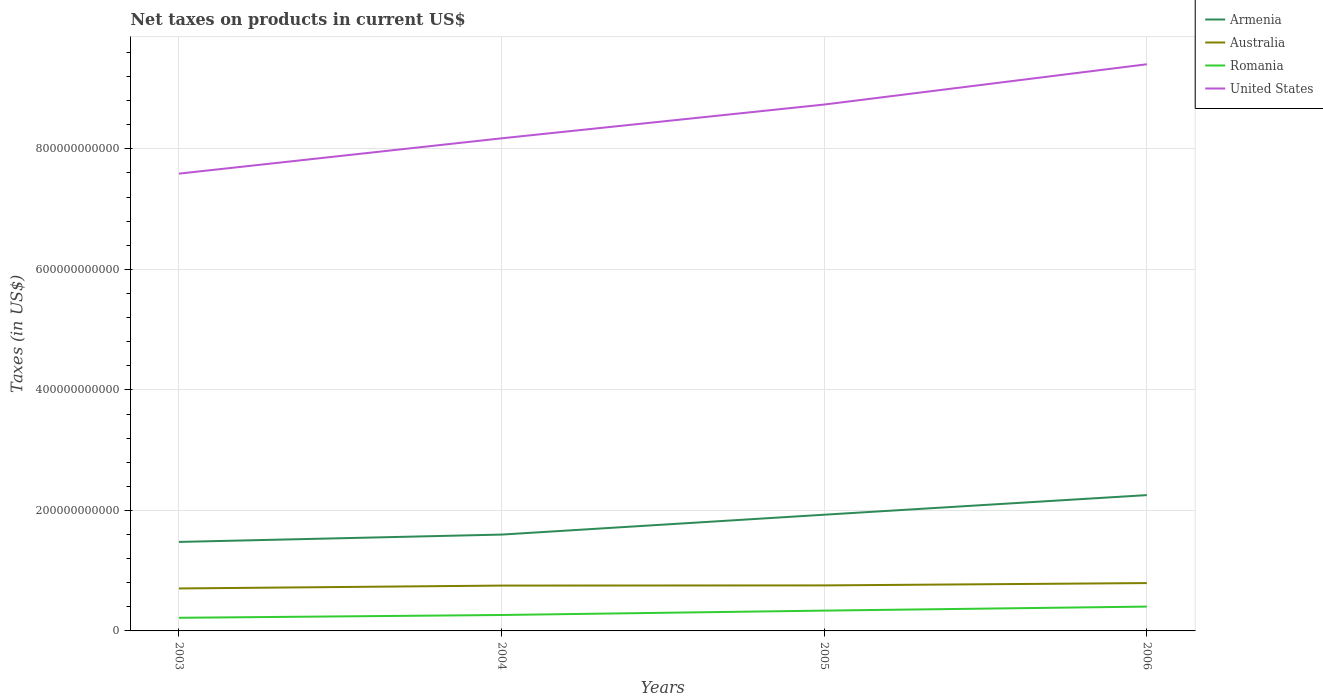How many different coloured lines are there?
Offer a very short reply. 4. Is the number of lines equal to the number of legend labels?
Offer a terse response. Yes. Across all years, what is the maximum net taxes on products in United States?
Offer a very short reply. 7.59e+11. In which year was the net taxes on products in United States maximum?
Your answer should be compact. 2003. What is the total net taxes on products in Armenia in the graph?
Keep it short and to the point. -6.55e+1. What is the difference between the highest and the second highest net taxes on products in Armenia?
Make the answer very short. 7.77e+1. How many years are there in the graph?
Make the answer very short. 4. What is the difference between two consecutive major ticks on the Y-axis?
Give a very brief answer. 2.00e+11. Does the graph contain grids?
Give a very brief answer. Yes. How many legend labels are there?
Keep it short and to the point. 4. What is the title of the graph?
Ensure brevity in your answer.  Net taxes on products in current US$. What is the label or title of the X-axis?
Your answer should be very brief. Years. What is the label or title of the Y-axis?
Offer a very short reply. Taxes (in US$). What is the Taxes (in US$) in Armenia in 2003?
Provide a succinct answer. 1.48e+11. What is the Taxes (in US$) in Australia in 2003?
Keep it short and to the point. 7.05e+1. What is the Taxes (in US$) of Romania in 2003?
Provide a succinct answer. 2.18e+1. What is the Taxes (in US$) in United States in 2003?
Offer a terse response. 7.59e+11. What is the Taxes (in US$) of Armenia in 2004?
Give a very brief answer. 1.60e+11. What is the Taxes (in US$) of Australia in 2004?
Offer a terse response. 7.53e+1. What is the Taxes (in US$) in Romania in 2004?
Offer a terse response. 2.64e+1. What is the Taxes (in US$) in United States in 2004?
Keep it short and to the point. 8.18e+11. What is the Taxes (in US$) of Armenia in 2005?
Provide a short and direct response. 1.93e+11. What is the Taxes (in US$) of Australia in 2005?
Make the answer very short. 7.55e+1. What is the Taxes (in US$) in Romania in 2005?
Your answer should be compact. 3.37e+1. What is the Taxes (in US$) of United States in 2005?
Your response must be concise. 8.74e+11. What is the Taxes (in US$) in Armenia in 2006?
Offer a terse response. 2.25e+11. What is the Taxes (in US$) in Australia in 2006?
Offer a very short reply. 7.94e+1. What is the Taxes (in US$) in Romania in 2006?
Provide a succinct answer. 4.04e+1. What is the Taxes (in US$) in United States in 2006?
Ensure brevity in your answer.  9.40e+11. Across all years, what is the maximum Taxes (in US$) of Armenia?
Ensure brevity in your answer.  2.25e+11. Across all years, what is the maximum Taxes (in US$) of Australia?
Make the answer very short. 7.94e+1. Across all years, what is the maximum Taxes (in US$) in Romania?
Keep it short and to the point. 4.04e+1. Across all years, what is the maximum Taxes (in US$) in United States?
Ensure brevity in your answer.  9.40e+11. Across all years, what is the minimum Taxes (in US$) in Armenia?
Your answer should be very brief. 1.48e+11. Across all years, what is the minimum Taxes (in US$) of Australia?
Your answer should be very brief. 7.05e+1. Across all years, what is the minimum Taxes (in US$) in Romania?
Ensure brevity in your answer.  2.18e+1. Across all years, what is the minimum Taxes (in US$) of United States?
Your answer should be very brief. 7.59e+11. What is the total Taxes (in US$) of Armenia in the graph?
Offer a very short reply. 7.26e+11. What is the total Taxes (in US$) of Australia in the graph?
Provide a short and direct response. 3.01e+11. What is the total Taxes (in US$) in Romania in the graph?
Keep it short and to the point. 1.22e+11. What is the total Taxes (in US$) of United States in the graph?
Keep it short and to the point. 3.39e+12. What is the difference between the Taxes (in US$) of Armenia in 2003 and that in 2004?
Offer a terse response. -1.22e+1. What is the difference between the Taxes (in US$) in Australia in 2003 and that in 2004?
Offer a terse response. -4.78e+09. What is the difference between the Taxes (in US$) in Romania in 2003 and that in 2004?
Ensure brevity in your answer.  -4.65e+09. What is the difference between the Taxes (in US$) in United States in 2003 and that in 2004?
Make the answer very short. -5.86e+1. What is the difference between the Taxes (in US$) in Armenia in 2003 and that in 2005?
Provide a succinct answer. -4.52e+1. What is the difference between the Taxes (in US$) in Australia in 2003 and that in 2005?
Make the answer very short. -5.05e+09. What is the difference between the Taxes (in US$) in Romania in 2003 and that in 2005?
Give a very brief answer. -1.19e+1. What is the difference between the Taxes (in US$) of United States in 2003 and that in 2005?
Provide a short and direct response. -1.15e+11. What is the difference between the Taxes (in US$) in Armenia in 2003 and that in 2006?
Provide a short and direct response. -7.77e+1. What is the difference between the Taxes (in US$) in Australia in 2003 and that in 2006?
Offer a terse response. -8.92e+09. What is the difference between the Taxes (in US$) of Romania in 2003 and that in 2006?
Ensure brevity in your answer.  -1.86e+1. What is the difference between the Taxes (in US$) in United States in 2003 and that in 2006?
Your response must be concise. -1.82e+11. What is the difference between the Taxes (in US$) in Armenia in 2004 and that in 2005?
Offer a very short reply. -3.30e+1. What is the difference between the Taxes (in US$) in Australia in 2004 and that in 2005?
Your response must be concise. -2.70e+08. What is the difference between the Taxes (in US$) of Romania in 2004 and that in 2005?
Offer a very short reply. -7.29e+09. What is the difference between the Taxes (in US$) of United States in 2004 and that in 2005?
Keep it short and to the point. -5.61e+1. What is the difference between the Taxes (in US$) of Armenia in 2004 and that in 2006?
Give a very brief answer. -6.55e+1. What is the difference between the Taxes (in US$) in Australia in 2004 and that in 2006?
Provide a short and direct response. -4.14e+09. What is the difference between the Taxes (in US$) in Romania in 2004 and that in 2006?
Your response must be concise. -1.39e+1. What is the difference between the Taxes (in US$) of United States in 2004 and that in 2006?
Your response must be concise. -1.23e+11. What is the difference between the Taxes (in US$) in Armenia in 2005 and that in 2006?
Offer a very short reply. -3.25e+1. What is the difference between the Taxes (in US$) of Australia in 2005 and that in 2006?
Provide a short and direct response. -3.87e+09. What is the difference between the Taxes (in US$) in Romania in 2005 and that in 2006?
Your response must be concise. -6.66e+09. What is the difference between the Taxes (in US$) in United States in 2005 and that in 2006?
Ensure brevity in your answer.  -6.69e+1. What is the difference between the Taxes (in US$) of Armenia in 2003 and the Taxes (in US$) of Australia in 2004?
Your answer should be compact. 7.24e+1. What is the difference between the Taxes (in US$) in Armenia in 2003 and the Taxes (in US$) in Romania in 2004?
Make the answer very short. 1.21e+11. What is the difference between the Taxes (in US$) of Armenia in 2003 and the Taxes (in US$) of United States in 2004?
Keep it short and to the point. -6.70e+11. What is the difference between the Taxes (in US$) in Australia in 2003 and the Taxes (in US$) in Romania in 2004?
Provide a succinct answer. 4.40e+1. What is the difference between the Taxes (in US$) of Australia in 2003 and the Taxes (in US$) of United States in 2004?
Provide a succinct answer. -7.47e+11. What is the difference between the Taxes (in US$) of Romania in 2003 and the Taxes (in US$) of United States in 2004?
Offer a very short reply. -7.96e+11. What is the difference between the Taxes (in US$) in Armenia in 2003 and the Taxes (in US$) in Australia in 2005?
Offer a terse response. 7.22e+1. What is the difference between the Taxes (in US$) of Armenia in 2003 and the Taxes (in US$) of Romania in 2005?
Keep it short and to the point. 1.14e+11. What is the difference between the Taxes (in US$) of Armenia in 2003 and the Taxes (in US$) of United States in 2005?
Provide a short and direct response. -7.26e+11. What is the difference between the Taxes (in US$) of Australia in 2003 and the Taxes (in US$) of Romania in 2005?
Give a very brief answer. 3.68e+1. What is the difference between the Taxes (in US$) of Australia in 2003 and the Taxes (in US$) of United States in 2005?
Keep it short and to the point. -8.03e+11. What is the difference between the Taxes (in US$) in Romania in 2003 and the Taxes (in US$) in United States in 2005?
Give a very brief answer. -8.52e+11. What is the difference between the Taxes (in US$) in Armenia in 2003 and the Taxes (in US$) in Australia in 2006?
Offer a terse response. 6.83e+1. What is the difference between the Taxes (in US$) of Armenia in 2003 and the Taxes (in US$) of Romania in 2006?
Provide a short and direct response. 1.07e+11. What is the difference between the Taxes (in US$) in Armenia in 2003 and the Taxes (in US$) in United States in 2006?
Your answer should be very brief. -7.93e+11. What is the difference between the Taxes (in US$) in Australia in 2003 and the Taxes (in US$) in Romania in 2006?
Keep it short and to the point. 3.01e+1. What is the difference between the Taxes (in US$) in Australia in 2003 and the Taxes (in US$) in United States in 2006?
Provide a short and direct response. -8.70e+11. What is the difference between the Taxes (in US$) of Romania in 2003 and the Taxes (in US$) of United States in 2006?
Keep it short and to the point. -9.19e+11. What is the difference between the Taxes (in US$) in Armenia in 2004 and the Taxes (in US$) in Australia in 2005?
Your answer should be compact. 8.44e+1. What is the difference between the Taxes (in US$) in Armenia in 2004 and the Taxes (in US$) in Romania in 2005?
Offer a terse response. 1.26e+11. What is the difference between the Taxes (in US$) in Armenia in 2004 and the Taxes (in US$) in United States in 2005?
Provide a short and direct response. -7.14e+11. What is the difference between the Taxes (in US$) in Australia in 2004 and the Taxes (in US$) in Romania in 2005?
Your response must be concise. 4.15e+1. What is the difference between the Taxes (in US$) of Australia in 2004 and the Taxes (in US$) of United States in 2005?
Offer a terse response. -7.98e+11. What is the difference between the Taxes (in US$) of Romania in 2004 and the Taxes (in US$) of United States in 2005?
Your answer should be compact. -8.47e+11. What is the difference between the Taxes (in US$) in Armenia in 2004 and the Taxes (in US$) in Australia in 2006?
Keep it short and to the point. 8.05e+1. What is the difference between the Taxes (in US$) in Armenia in 2004 and the Taxes (in US$) in Romania in 2006?
Offer a terse response. 1.20e+11. What is the difference between the Taxes (in US$) of Armenia in 2004 and the Taxes (in US$) of United States in 2006?
Make the answer very short. -7.81e+11. What is the difference between the Taxes (in US$) in Australia in 2004 and the Taxes (in US$) in Romania in 2006?
Give a very brief answer. 3.49e+1. What is the difference between the Taxes (in US$) in Australia in 2004 and the Taxes (in US$) in United States in 2006?
Offer a very short reply. -8.65e+11. What is the difference between the Taxes (in US$) in Romania in 2004 and the Taxes (in US$) in United States in 2006?
Ensure brevity in your answer.  -9.14e+11. What is the difference between the Taxes (in US$) of Armenia in 2005 and the Taxes (in US$) of Australia in 2006?
Provide a short and direct response. 1.13e+11. What is the difference between the Taxes (in US$) in Armenia in 2005 and the Taxes (in US$) in Romania in 2006?
Provide a succinct answer. 1.52e+11. What is the difference between the Taxes (in US$) in Armenia in 2005 and the Taxes (in US$) in United States in 2006?
Your response must be concise. -7.48e+11. What is the difference between the Taxes (in US$) in Australia in 2005 and the Taxes (in US$) in Romania in 2006?
Ensure brevity in your answer.  3.52e+1. What is the difference between the Taxes (in US$) of Australia in 2005 and the Taxes (in US$) of United States in 2006?
Provide a succinct answer. -8.65e+11. What is the difference between the Taxes (in US$) of Romania in 2005 and the Taxes (in US$) of United States in 2006?
Your answer should be very brief. -9.07e+11. What is the average Taxes (in US$) of Armenia per year?
Provide a short and direct response. 1.81e+11. What is the average Taxes (in US$) of Australia per year?
Your answer should be very brief. 7.52e+1. What is the average Taxes (in US$) in Romania per year?
Keep it short and to the point. 3.06e+1. What is the average Taxes (in US$) in United States per year?
Make the answer very short. 8.48e+11. In the year 2003, what is the difference between the Taxes (in US$) in Armenia and Taxes (in US$) in Australia?
Ensure brevity in your answer.  7.72e+1. In the year 2003, what is the difference between the Taxes (in US$) in Armenia and Taxes (in US$) in Romania?
Keep it short and to the point. 1.26e+11. In the year 2003, what is the difference between the Taxes (in US$) in Armenia and Taxes (in US$) in United States?
Your response must be concise. -6.11e+11. In the year 2003, what is the difference between the Taxes (in US$) in Australia and Taxes (in US$) in Romania?
Ensure brevity in your answer.  4.87e+1. In the year 2003, what is the difference between the Taxes (in US$) in Australia and Taxes (in US$) in United States?
Ensure brevity in your answer.  -6.88e+11. In the year 2003, what is the difference between the Taxes (in US$) in Romania and Taxes (in US$) in United States?
Offer a terse response. -7.37e+11. In the year 2004, what is the difference between the Taxes (in US$) of Armenia and Taxes (in US$) of Australia?
Offer a very short reply. 8.46e+1. In the year 2004, what is the difference between the Taxes (in US$) in Armenia and Taxes (in US$) in Romania?
Offer a terse response. 1.33e+11. In the year 2004, what is the difference between the Taxes (in US$) in Armenia and Taxes (in US$) in United States?
Provide a short and direct response. -6.58e+11. In the year 2004, what is the difference between the Taxes (in US$) of Australia and Taxes (in US$) of Romania?
Provide a short and direct response. 4.88e+1. In the year 2004, what is the difference between the Taxes (in US$) in Australia and Taxes (in US$) in United States?
Provide a succinct answer. -7.42e+11. In the year 2004, what is the difference between the Taxes (in US$) of Romania and Taxes (in US$) of United States?
Your response must be concise. -7.91e+11. In the year 2005, what is the difference between the Taxes (in US$) of Armenia and Taxes (in US$) of Australia?
Provide a short and direct response. 1.17e+11. In the year 2005, what is the difference between the Taxes (in US$) of Armenia and Taxes (in US$) of Romania?
Offer a terse response. 1.59e+11. In the year 2005, what is the difference between the Taxes (in US$) in Armenia and Taxes (in US$) in United States?
Offer a very short reply. -6.81e+11. In the year 2005, what is the difference between the Taxes (in US$) of Australia and Taxes (in US$) of Romania?
Your answer should be compact. 4.18e+1. In the year 2005, what is the difference between the Taxes (in US$) in Australia and Taxes (in US$) in United States?
Provide a short and direct response. -7.98e+11. In the year 2005, what is the difference between the Taxes (in US$) in Romania and Taxes (in US$) in United States?
Provide a short and direct response. -8.40e+11. In the year 2006, what is the difference between the Taxes (in US$) of Armenia and Taxes (in US$) of Australia?
Your answer should be compact. 1.46e+11. In the year 2006, what is the difference between the Taxes (in US$) in Armenia and Taxes (in US$) in Romania?
Offer a very short reply. 1.85e+11. In the year 2006, what is the difference between the Taxes (in US$) of Armenia and Taxes (in US$) of United States?
Your response must be concise. -7.15e+11. In the year 2006, what is the difference between the Taxes (in US$) of Australia and Taxes (in US$) of Romania?
Ensure brevity in your answer.  3.90e+1. In the year 2006, what is the difference between the Taxes (in US$) in Australia and Taxes (in US$) in United States?
Offer a very short reply. -8.61e+11. In the year 2006, what is the difference between the Taxes (in US$) of Romania and Taxes (in US$) of United States?
Give a very brief answer. -9.00e+11. What is the ratio of the Taxes (in US$) of Armenia in 2003 to that in 2004?
Provide a succinct answer. 0.92. What is the ratio of the Taxes (in US$) of Australia in 2003 to that in 2004?
Keep it short and to the point. 0.94. What is the ratio of the Taxes (in US$) of Romania in 2003 to that in 2004?
Offer a terse response. 0.82. What is the ratio of the Taxes (in US$) of United States in 2003 to that in 2004?
Keep it short and to the point. 0.93. What is the ratio of the Taxes (in US$) of Armenia in 2003 to that in 2005?
Make the answer very short. 0.77. What is the ratio of the Taxes (in US$) of Australia in 2003 to that in 2005?
Your answer should be compact. 0.93. What is the ratio of the Taxes (in US$) in Romania in 2003 to that in 2005?
Your answer should be very brief. 0.65. What is the ratio of the Taxes (in US$) in United States in 2003 to that in 2005?
Ensure brevity in your answer.  0.87. What is the ratio of the Taxes (in US$) in Armenia in 2003 to that in 2006?
Offer a terse response. 0.66. What is the ratio of the Taxes (in US$) of Australia in 2003 to that in 2006?
Your answer should be very brief. 0.89. What is the ratio of the Taxes (in US$) in Romania in 2003 to that in 2006?
Offer a very short reply. 0.54. What is the ratio of the Taxes (in US$) in United States in 2003 to that in 2006?
Keep it short and to the point. 0.81. What is the ratio of the Taxes (in US$) of Armenia in 2004 to that in 2005?
Provide a succinct answer. 0.83. What is the ratio of the Taxes (in US$) of Romania in 2004 to that in 2005?
Offer a very short reply. 0.78. What is the ratio of the Taxes (in US$) in United States in 2004 to that in 2005?
Give a very brief answer. 0.94. What is the ratio of the Taxes (in US$) of Armenia in 2004 to that in 2006?
Your answer should be very brief. 0.71. What is the ratio of the Taxes (in US$) in Australia in 2004 to that in 2006?
Offer a terse response. 0.95. What is the ratio of the Taxes (in US$) in Romania in 2004 to that in 2006?
Provide a succinct answer. 0.65. What is the ratio of the Taxes (in US$) in United States in 2004 to that in 2006?
Offer a terse response. 0.87. What is the ratio of the Taxes (in US$) in Armenia in 2005 to that in 2006?
Offer a very short reply. 0.86. What is the ratio of the Taxes (in US$) in Australia in 2005 to that in 2006?
Give a very brief answer. 0.95. What is the ratio of the Taxes (in US$) in Romania in 2005 to that in 2006?
Provide a succinct answer. 0.84. What is the ratio of the Taxes (in US$) in United States in 2005 to that in 2006?
Offer a very short reply. 0.93. What is the difference between the highest and the second highest Taxes (in US$) of Armenia?
Give a very brief answer. 3.25e+1. What is the difference between the highest and the second highest Taxes (in US$) in Australia?
Your answer should be very brief. 3.87e+09. What is the difference between the highest and the second highest Taxes (in US$) of Romania?
Offer a terse response. 6.66e+09. What is the difference between the highest and the second highest Taxes (in US$) in United States?
Ensure brevity in your answer.  6.69e+1. What is the difference between the highest and the lowest Taxes (in US$) of Armenia?
Your response must be concise. 7.77e+1. What is the difference between the highest and the lowest Taxes (in US$) in Australia?
Your answer should be compact. 8.92e+09. What is the difference between the highest and the lowest Taxes (in US$) in Romania?
Your answer should be compact. 1.86e+1. What is the difference between the highest and the lowest Taxes (in US$) of United States?
Your answer should be very brief. 1.82e+11. 